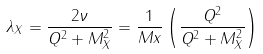Convert formula to latex. <formula><loc_0><loc_0><loc_500><loc_500>\lambda _ { X } = \frac { 2 \nu } { Q ^ { 2 } + M _ { X } ^ { 2 } } = \frac { 1 } { M x } \left ( \frac { Q ^ { 2 } } { Q ^ { 2 } + M _ { X } ^ { 2 } } \right )</formula> 